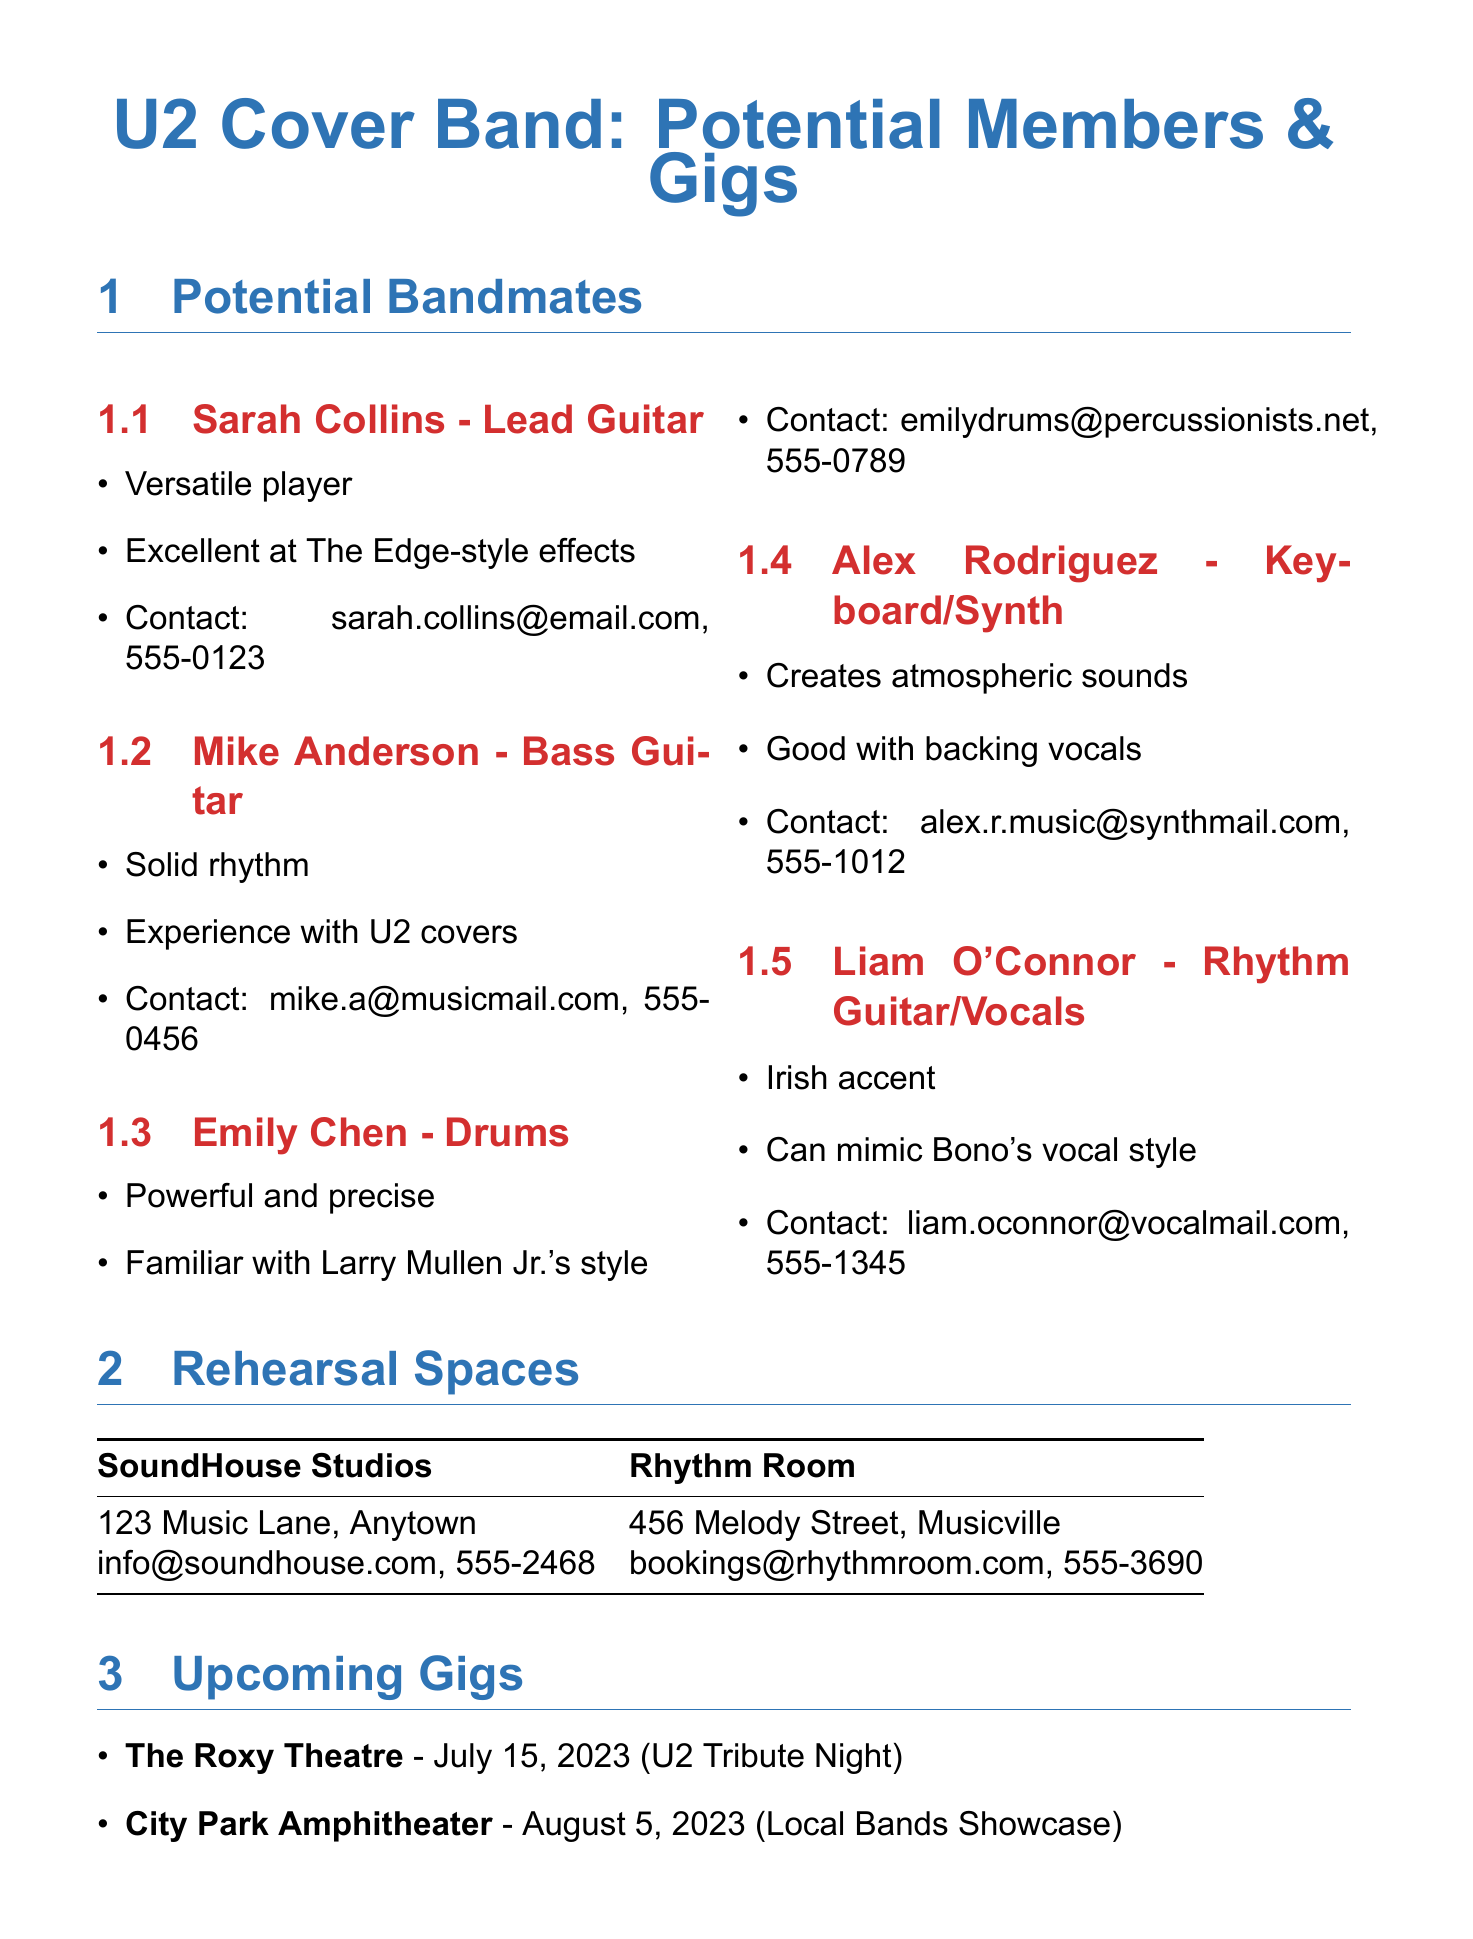What is the name of the lead guitarist? The lead guitarist is Sarah Collins, listed under potential bandmates.
Answer: Sarah Collins What is Mike Anderson's strength? Mike Anderson is described as having solid rhythm and experience with U2 covers.
Answer: Solid rhythm Which instrument does Emily Chen play? Emily Chen is listed as the drummer among the potential bandmates.
Answer: Drums What date is the U2 Tribute Night scheduled for? The U2 Tribute Night at The Roxy Theatre is on July 15, 2023, as mentioned in the upcoming gigs section.
Answer: July 15, 2023 Which rehearsal space has a contact email starting with "bookings"? The Rhythm Room has a contact email that starts with "bookings".
Answer: Rhythm Room What musical style is Liam O'Connor known for mimicking? Liam O'Connor can mimic Bono's vocal style, which is noted as his strength.
Answer: Bono's vocal style How many potential bandmates are listed? There are five potential bandmates listed in the document.
Answer: Five What is Alex Rodriguez's strength? Alex Rodriguez is noted for creating atmospheric sounds and being good with backing vocals.
Answer: Atmospheric sounds Where is SoundHouse Studios located? SoundHouse Studios is located at 123 Music Lane, Anytown, as stated in the rehearsal spaces section.
Answer: 123 Music Lane, Anytown 